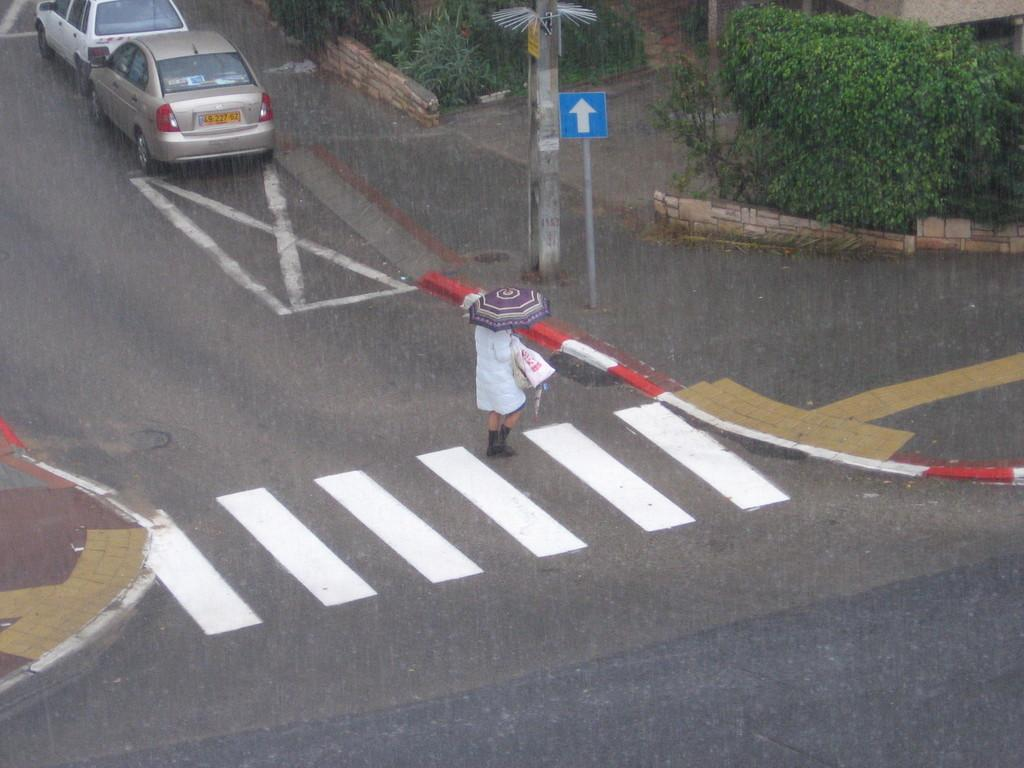What is the person in the image holding? The person is holding an umbrella in the image. What can be seen in the background of the image? There is an electric pole in the image. What type of natural elements are present in the image? There are plants in the image. What type of man-made structure is visible in the image? There is a vehicle in the image. What surface is the person and vehicle standing on? There is a road in the image. Where are the chickens located in the image? There are no chickens present in the image. What type of fiction is the person reading under the umbrella? There is no indication that the person is reading any fiction in the image. 